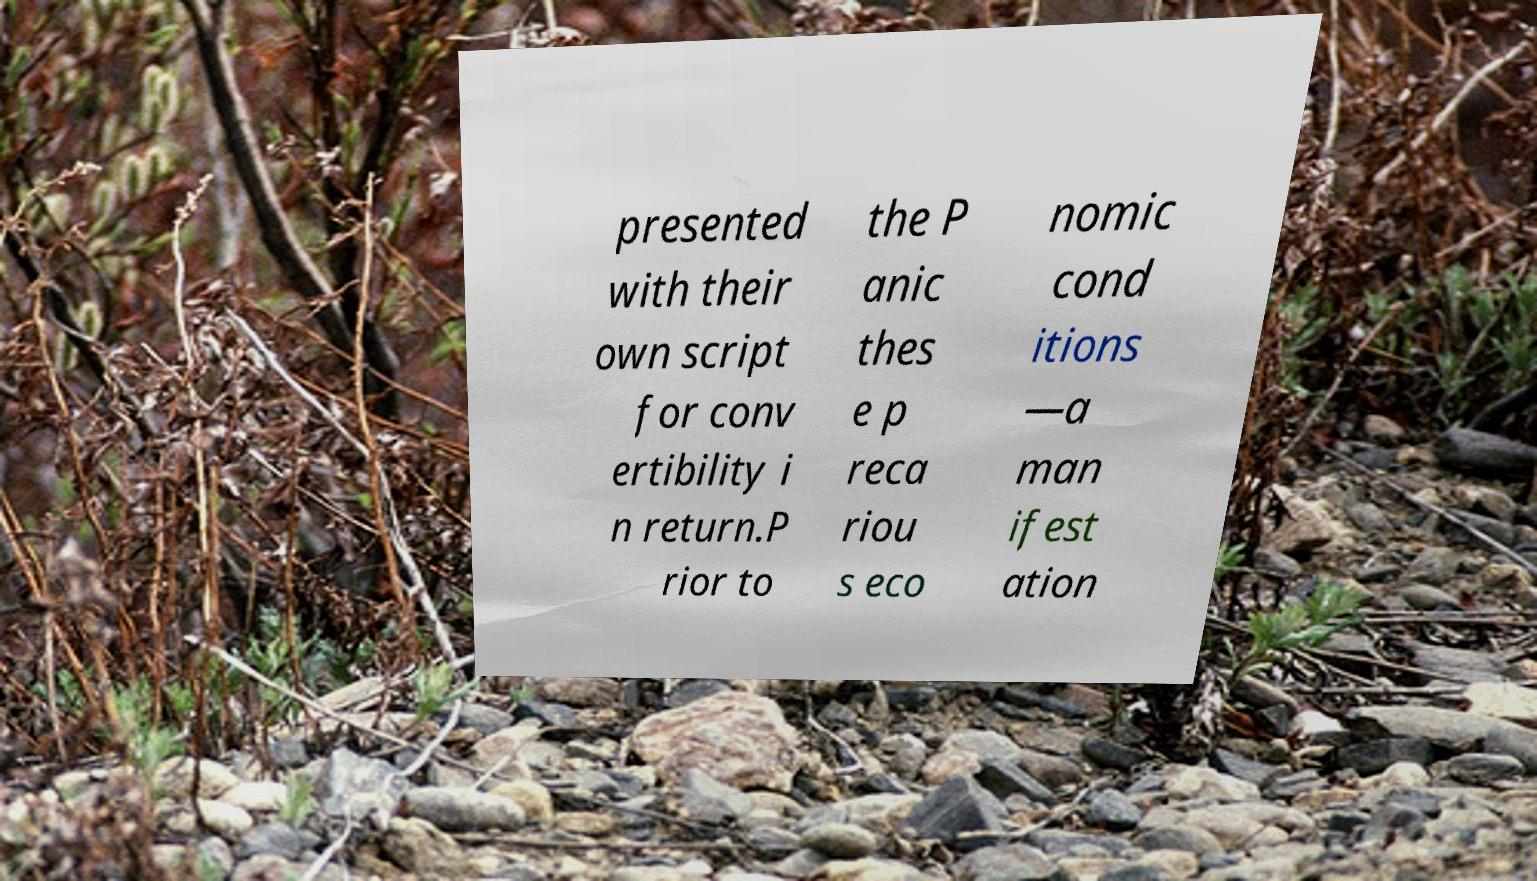Can you read and provide the text displayed in the image?This photo seems to have some interesting text. Can you extract and type it out for me? presented with their own script for conv ertibility i n return.P rior to the P anic thes e p reca riou s eco nomic cond itions —a man ifest ation 